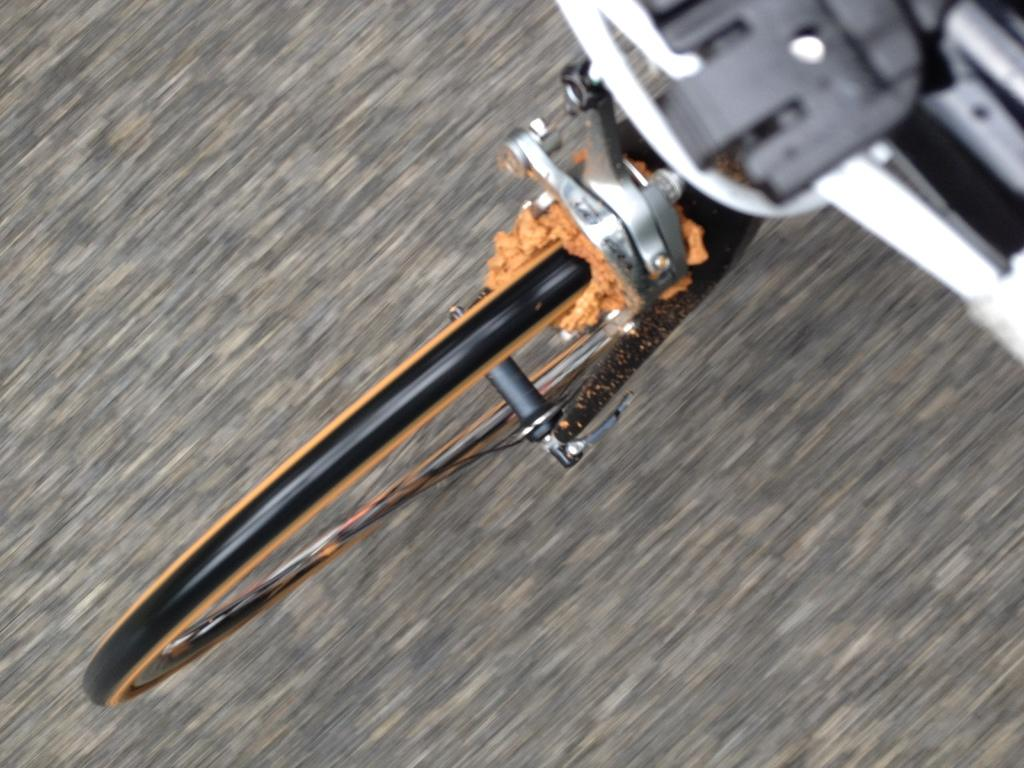What is the main feature of the image? There is a road in the image. What mode of transportation can be seen in the image? There is a bicycle in the image. Which part of the bicycle is visible in the image? The front tire and handle of the bicycle are visible. What type of horn is attached to the front of the bicycle in the image? There is no horn attached to the front of the bicycle in the image. 